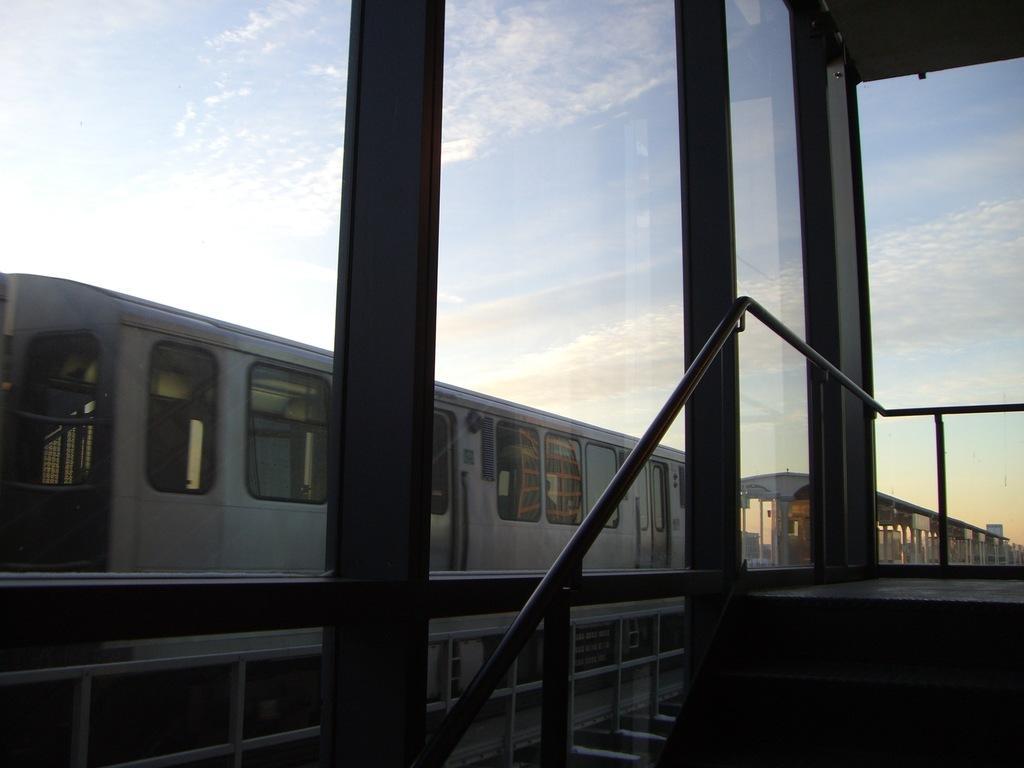In one or two sentences, can you explain what this image depicts? In this image I can see train and a clear blue sky. 